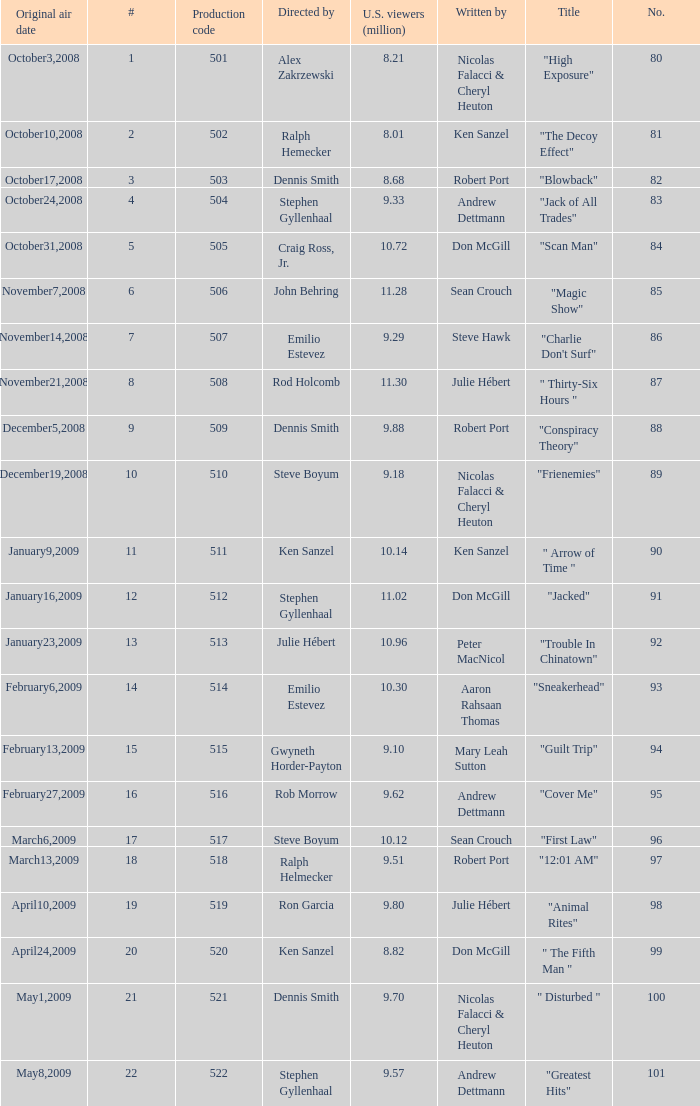How many times did episode 6 originally air? 1.0. 